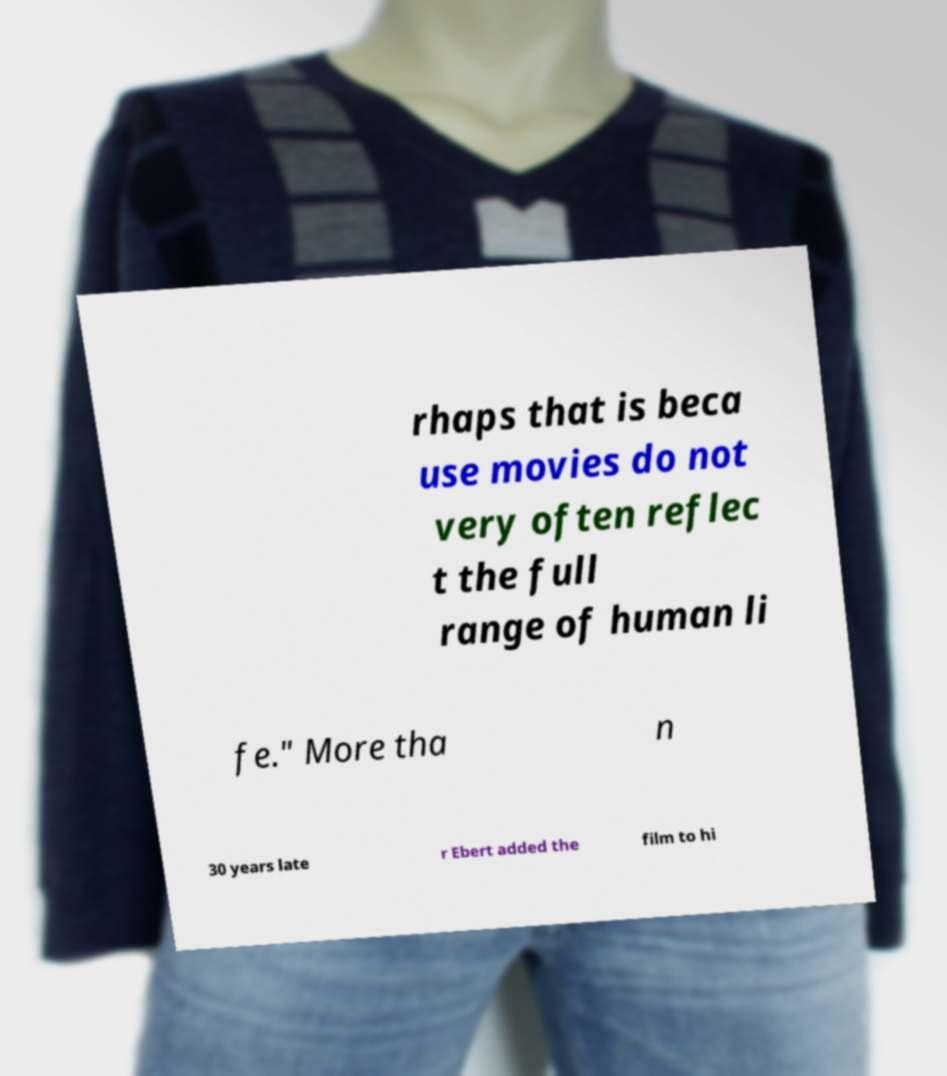Please read and relay the text visible in this image. What does it say? rhaps that is beca use movies do not very often reflec t the full range of human li fe." More tha n 30 years late r Ebert added the film to hi 